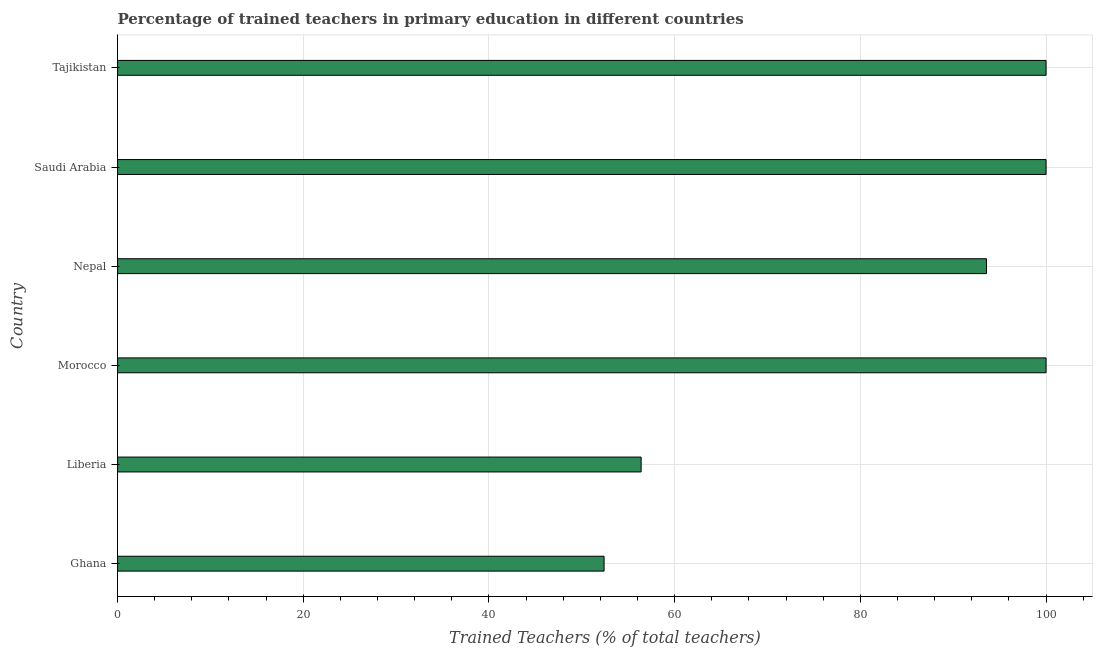Does the graph contain any zero values?
Your answer should be compact. No. What is the title of the graph?
Offer a terse response. Percentage of trained teachers in primary education in different countries. What is the label or title of the X-axis?
Your answer should be compact. Trained Teachers (% of total teachers). What is the label or title of the Y-axis?
Your answer should be compact. Country. Across all countries, what is the minimum percentage of trained teachers?
Make the answer very short. 52.4. In which country was the percentage of trained teachers maximum?
Give a very brief answer. Morocco. What is the sum of the percentage of trained teachers?
Provide a short and direct response. 502.37. What is the difference between the percentage of trained teachers in Nepal and Tajikistan?
Make the answer very short. -6.42. What is the average percentage of trained teachers per country?
Keep it short and to the point. 83.73. What is the median percentage of trained teachers?
Offer a terse response. 96.79. What is the ratio of the percentage of trained teachers in Ghana to that in Liberia?
Your answer should be compact. 0.93. Is the percentage of trained teachers in Morocco less than that in Tajikistan?
Provide a short and direct response. No. Is the difference between the percentage of trained teachers in Nepal and Saudi Arabia greater than the difference between any two countries?
Provide a short and direct response. No. What is the difference between the highest and the lowest percentage of trained teachers?
Your answer should be very brief. 47.6. How many countries are there in the graph?
Offer a terse response. 6. What is the difference between two consecutive major ticks on the X-axis?
Offer a very short reply. 20. What is the Trained Teachers (% of total teachers) of Ghana?
Give a very brief answer. 52.4. What is the Trained Teachers (% of total teachers) in Liberia?
Keep it short and to the point. 56.39. What is the Trained Teachers (% of total teachers) in Morocco?
Give a very brief answer. 100. What is the Trained Teachers (% of total teachers) of Nepal?
Ensure brevity in your answer.  93.58. What is the Trained Teachers (% of total teachers) of Saudi Arabia?
Offer a very short reply. 100. What is the Trained Teachers (% of total teachers) of Tajikistan?
Make the answer very short. 100. What is the difference between the Trained Teachers (% of total teachers) in Ghana and Liberia?
Give a very brief answer. -3.99. What is the difference between the Trained Teachers (% of total teachers) in Ghana and Morocco?
Provide a succinct answer. -47.6. What is the difference between the Trained Teachers (% of total teachers) in Ghana and Nepal?
Make the answer very short. -41.18. What is the difference between the Trained Teachers (% of total teachers) in Ghana and Saudi Arabia?
Your response must be concise. -47.6. What is the difference between the Trained Teachers (% of total teachers) in Ghana and Tajikistan?
Provide a short and direct response. -47.6. What is the difference between the Trained Teachers (% of total teachers) in Liberia and Morocco?
Give a very brief answer. -43.61. What is the difference between the Trained Teachers (% of total teachers) in Liberia and Nepal?
Ensure brevity in your answer.  -37.19. What is the difference between the Trained Teachers (% of total teachers) in Liberia and Saudi Arabia?
Give a very brief answer. -43.61. What is the difference between the Trained Teachers (% of total teachers) in Liberia and Tajikistan?
Offer a terse response. -43.61. What is the difference between the Trained Teachers (% of total teachers) in Morocco and Nepal?
Give a very brief answer. 6.42. What is the difference between the Trained Teachers (% of total teachers) in Morocco and Saudi Arabia?
Your answer should be very brief. 0. What is the difference between the Trained Teachers (% of total teachers) in Nepal and Saudi Arabia?
Provide a short and direct response. -6.42. What is the difference between the Trained Teachers (% of total teachers) in Nepal and Tajikistan?
Offer a terse response. -6.42. What is the ratio of the Trained Teachers (% of total teachers) in Ghana to that in Liberia?
Offer a terse response. 0.93. What is the ratio of the Trained Teachers (% of total teachers) in Ghana to that in Morocco?
Provide a short and direct response. 0.52. What is the ratio of the Trained Teachers (% of total teachers) in Ghana to that in Nepal?
Offer a very short reply. 0.56. What is the ratio of the Trained Teachers (% of total teachers) in Ghana to that in Saudi Arabia?
Offer a very short reply. 0.52. What is the ratio of the Trained Teachers (% of total teachers) in Ghana to that in Tajikistan?
Offer a very short reply. 0.52. What is the ratio of the Trained Teachers (% of total teachers) in Liberia to that in Morocco?
Your answer should be very brief. 0.56. What is the ratio of the Trained Teachers (% of total teachers) in Liberia to that in Nepal?
Your response must be concise. 0.6. What is the ratio of the Trained Teachers (% of total teachers) in Liberia to that in Saudi Arabia?
Your response must be concise. 0.56. What is the ratio of the Trained Teachers (% of total teachers) in Liberia to that in Tajikistan?
Provide a succinct answer. 0.56. What is the ratio of the Trained Teachers (% of total teachers) in Morocco to that in Nepal?
Make the answer very short. 1.07. What is the ratio of the Trained Teachers (% of total teachers) in Morocco to that in Saudi Arabia?
Make the answer very short. 1. What is the ratio of the Trained Teachers (% of total teachers) in Nepal to that in Saudi Arabia?
Give a very brief answer. 0.94. What is the ratio of the Trained Teachers (% of total teachers) in Nepal to that in Tajikistan?
Ensure brevity in your answer.  0.94. 